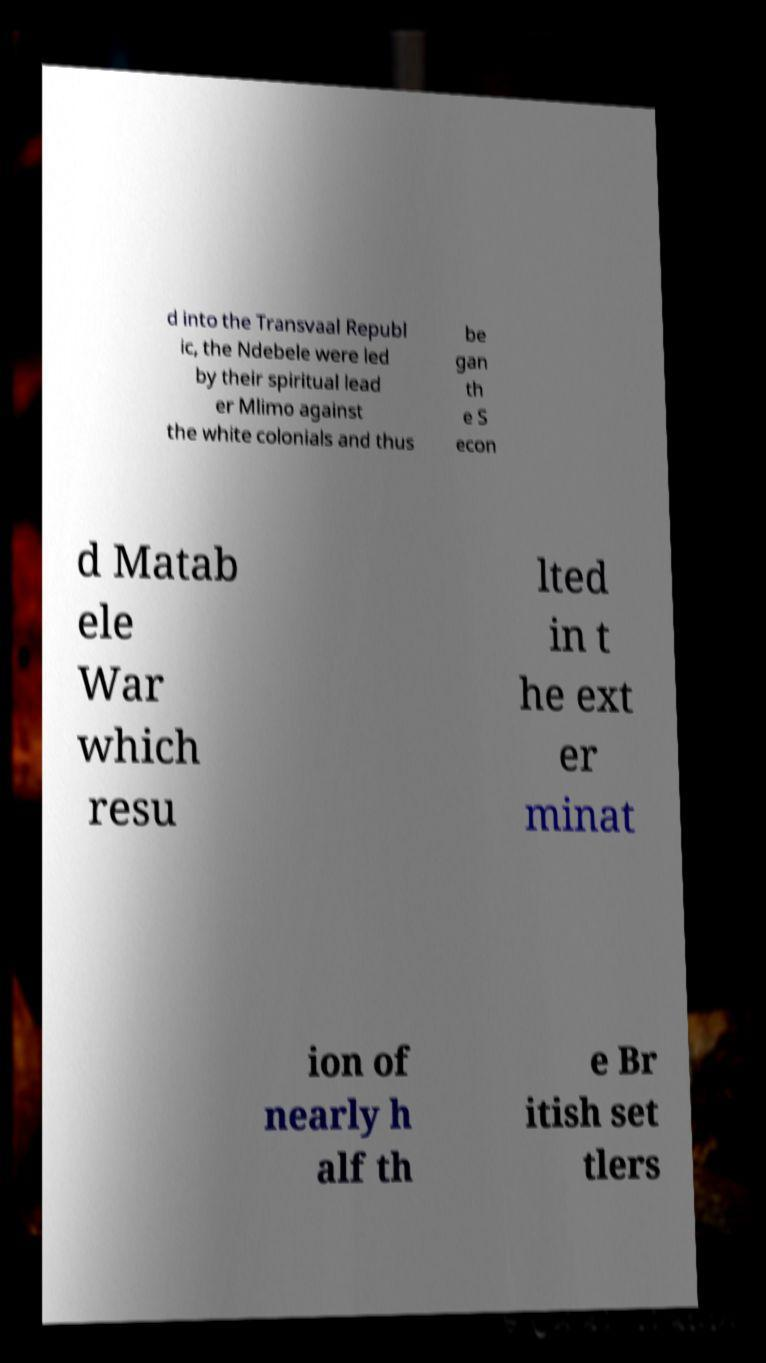What messages or text are displayed in this image? I need them in a readable, typed format. d into the Transvaal Republ ic, the Ndebele were led by their spiritual lead er Mlimo against the white colonials and thus be gan th e S econ d Matab ele War which resu lted in t he ext er minat ion of nearly h alf th e Br itish set tlers 